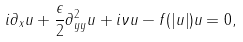<formula> <loc_0><loc_0><loc_500><loc_500>i \partial _ { x } u + { \frac { \epsilon } { 2 } } \partial ^ { 2 } _ { y y } u + i \nu u - f ( | u | ) u = 0 ,</formula> 